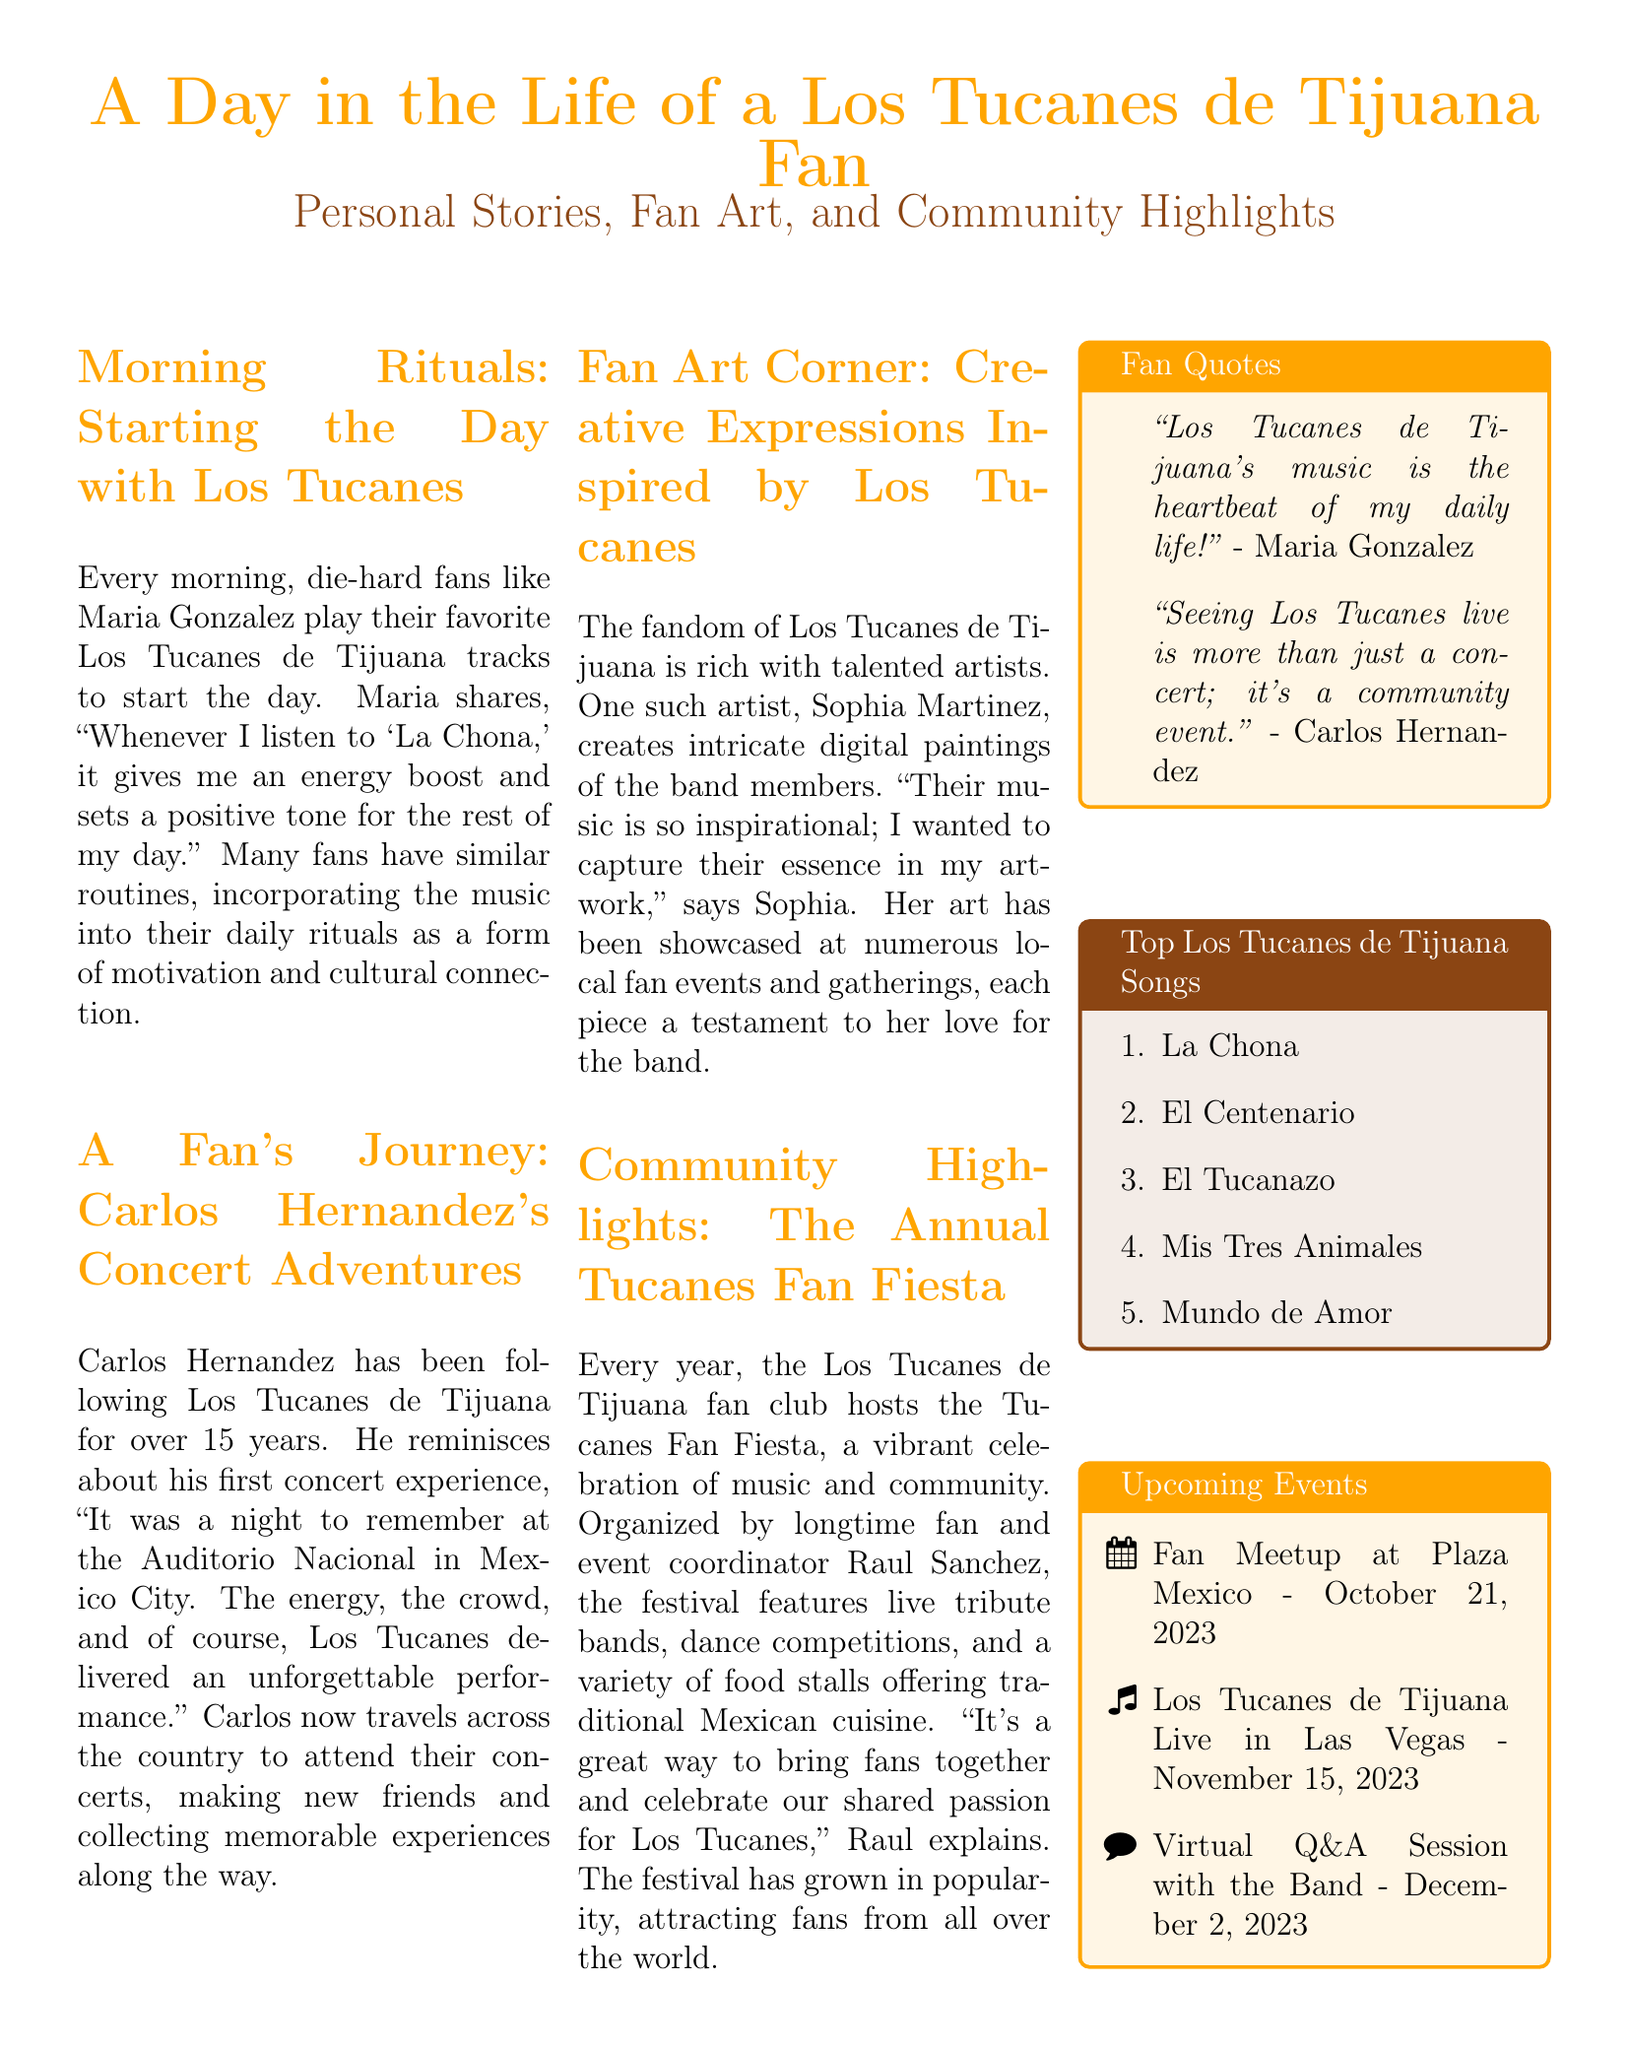What song does Maria Gonzalez listen to in the morning? The document states that Maria plays her favorite Los Tucanes de Tijuana tracks, specifically mentioning "La Chona."
Answer: La Chona How many years has Carlos Hernandez been following Los Tucanes de Tijuana? Carlos has been following the band for over 15 years, according to his journey shared in the document.
Answer: 15 years Who creates digital paintings of the band members? Sophia Martinez is the artist mentioned in the document who creates intricate digital paintings of Los Tucanes de Tijuana.
Answer: Sophia Martinez What event is organized by Raul Sanchez? The document describes the Tucanes Fan Fiesta, which is organized by Raul Sanchez.
Answer: Tucanes Fan Fiesta What is the date of the upcoming Fan Meetup at Plaza Mexico? The document states the fan meetup is scheduled for October 21, 2023.
Answer: October 21, 2023 Which song is listed first in the Top Los Tucanes de Tijuana Songs? The list of top songs begins with "La Chona."
Answer: La Chona What is the purpose of the Tucanes Fan Fiesta? The festival aims to bring fans together and celebrate their shared passion for Los Tucanes.
Answer: Celebrate shared passion What type of session will happen on December 2, 2023? A virtual Q&A session with the band is scheduled for that date according to the document.
Answer: Virtual Q&A Session Which memory is Carlos Hernandez reminded of when talking about his first concert? Carlos reminisces about the unforgettable performance at the Auditorio Nacional in Mexico City.
Answer: Auditorio Nacional What food is featured at the Tucanes Fan Fiesta? The document mentions that the festival offers a variety of food stalls featuring traditional Mexican cuisine.
Answer: Traditional Mexican cuisine 